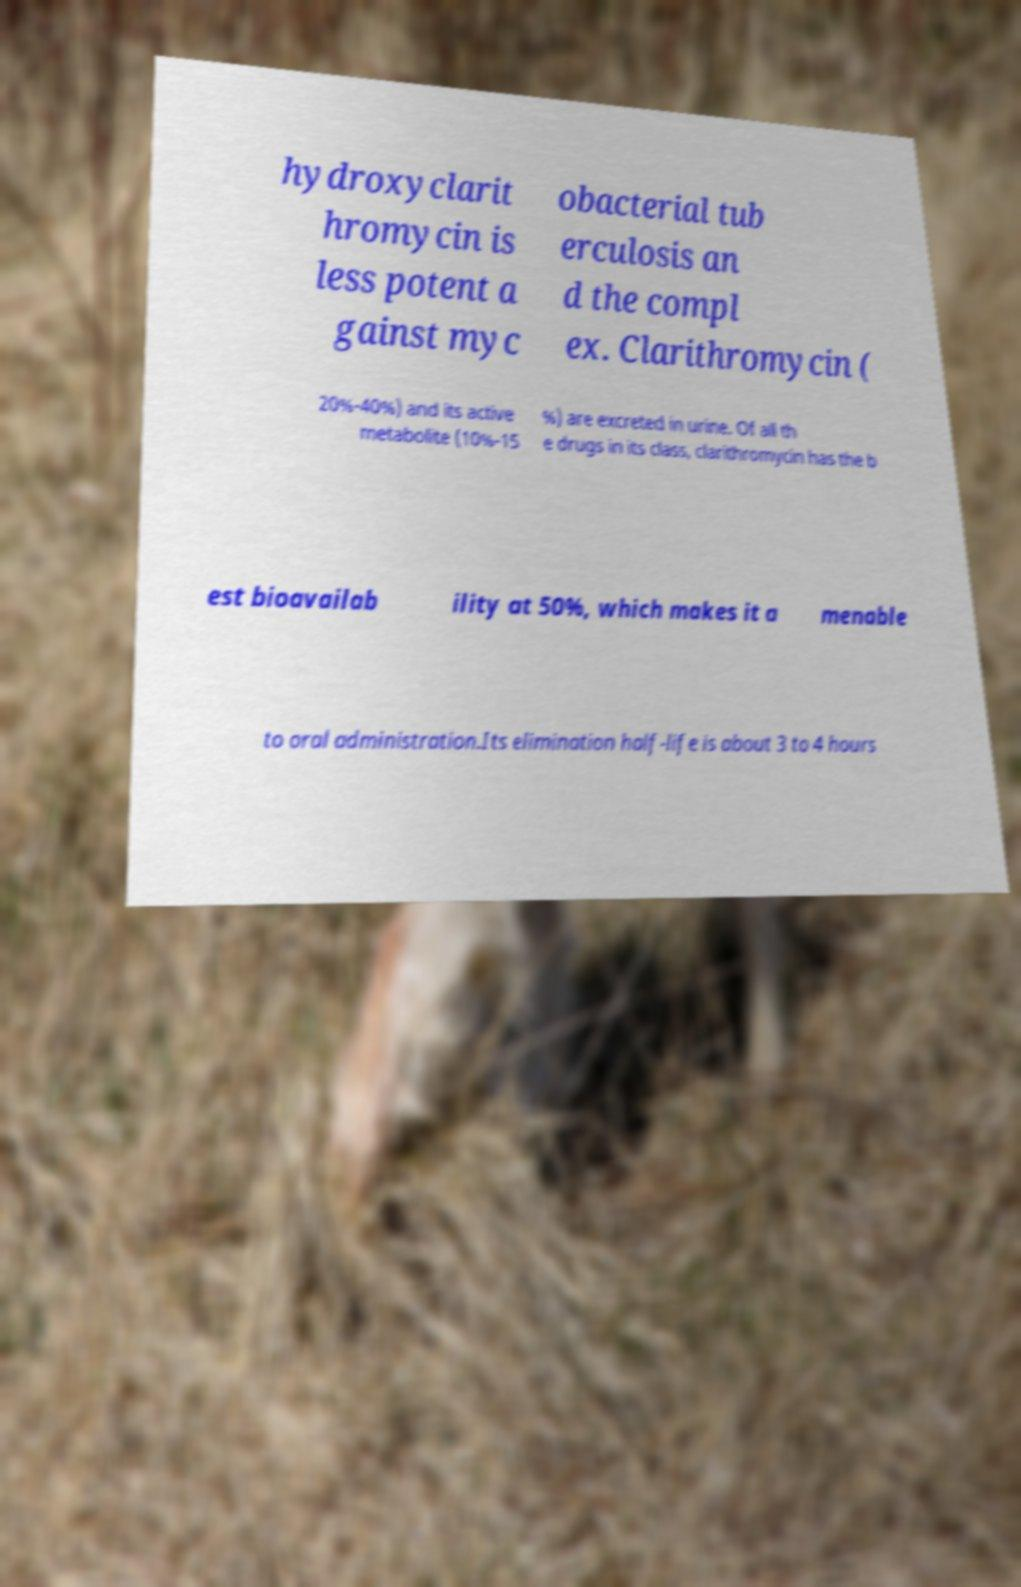For documentation purposes, I need the text within this image transcribed. Could you provide that? hydroxyclarit hromycin is less potent a gainst myc obacterial tub erculosis an d the compl ex. Clarithromycin ( 20%-40%) and its active metabolite (10%-15 %) are excreted in urine. Of all th e drugs in its class, clarithromycin has the b est bioavailab ility at 50%, which makes it a menable to oral administration.Its elimination half-life is about 3 to 4 hours 